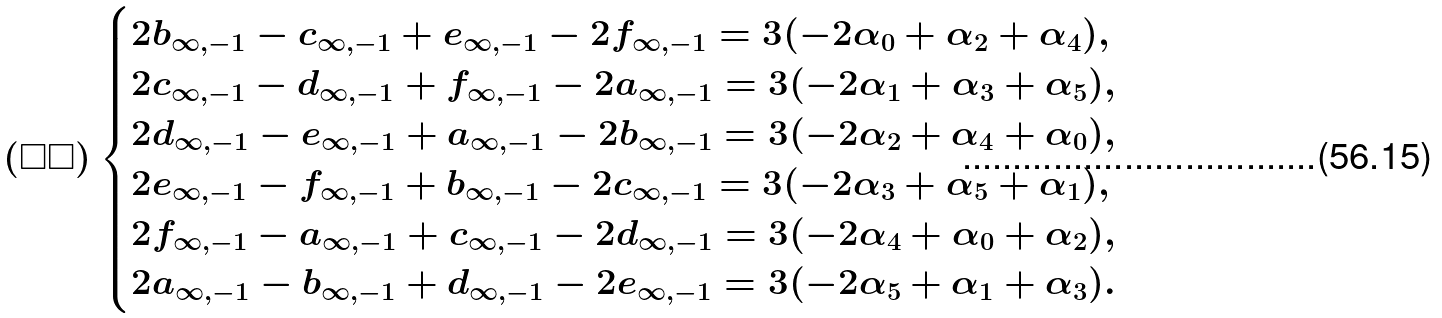<formula> <loc_0><loc_0><loc_500><loc_500>( \square \square ) \begin{cases} 2 b _ { \infty , - 1 } - c _ { \infty , - 1 } + e _ { \infty , - 1 } - 2 f _ { \infty , - 1 } = 3 ( - 2 \alpha _ { 0 } + \alpha _ { 2 } + \alpha _ { 4 } ) , \\ 2 c _ { \infty , - 1 } - d _ { \infty , - 1 } + f _ { \infty , - 1 } - 2 a _ { \infty , - 1 } = 3 ( - 2 \alpha _ { 1 } + \alpha _ { 3 } + \alpha _ { 5 } ) , \\ 2 d _ { \infty , - 1 } - e _ { \infty , - 1 } + a _ { \infty , - 1 } - 2 b _ { \infty , - 1 } = 3 ( - 2 \alpha _ { 2 } + \alpha _ { 4 } + \alpha _ { 0 } ) , \\ 2 e _ { \infty , - 1 } - f _ { \infty , - 1 } + b _ { \infty , - 1 } - 2 c _ { \infty , - 1 } = 3 ( - 2 \alpha _ { 3 } + \alpha _ { 5 } + \alpha _ { 1 } ) , \\ 2 f _ { \infty , - 1 } - a _ { \infty , - 1 } + c _ { \infty , - 1 } - 2 d _ { \infty , - 1 } = 3 ( - 2 \alpha _ { 4 } + \alpha _ { 0 } + \alpha _ { 2 } ) , \\ 2 a _ { \infty , - 1 } - b _ { \infty , - 1 } + d _ { \infty , - 1 } - 2 e _ { \infty , - 1 } = 3 ( - 2 \alpha _ { 5 } + \alpha _ { 1 } + \alpha _ { 3 } ) . \end{cases}</formula> 